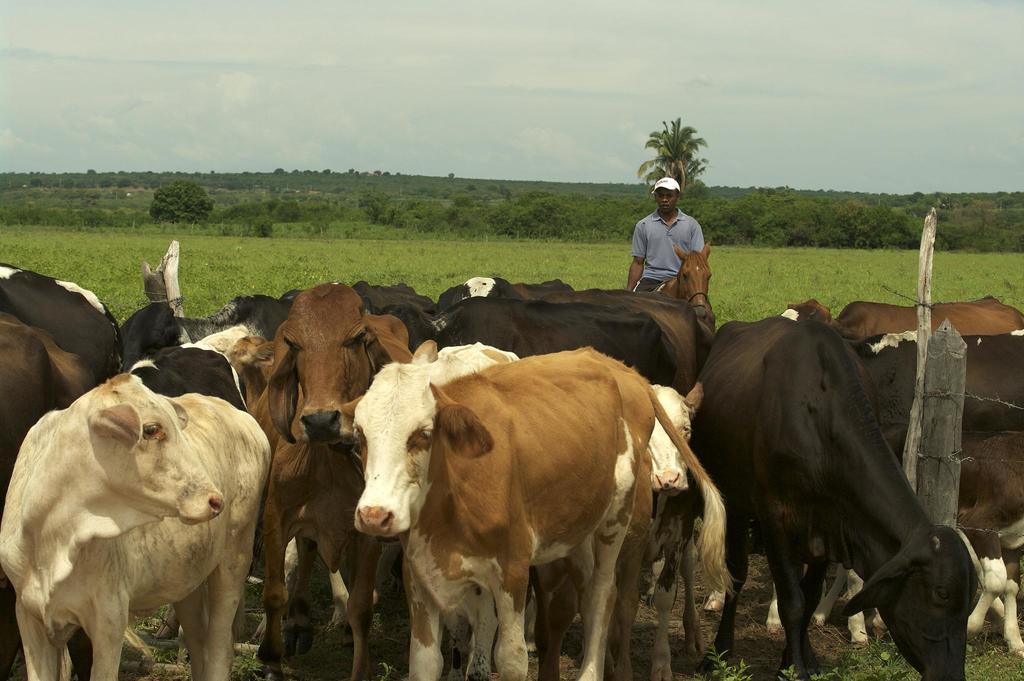What animals are in the center of the image? There are cows and a horse in the center of the image. Who is present in the image? There is a man standing in the image. What can be seen in the background of the image? There are trees and sky visible in the background of the image. What feature is present to separate the animals from the surrounding area? There is a fence in the image. Is there any fire visible in the image? No, there is no fire present in the image. Can you tell me how deep the quicksand is in the image? There is no quicksand present in the image. 